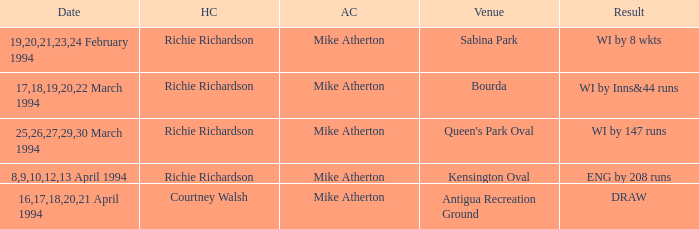Which Home Captain has Eng by 208 runs? Richie Richardson. 